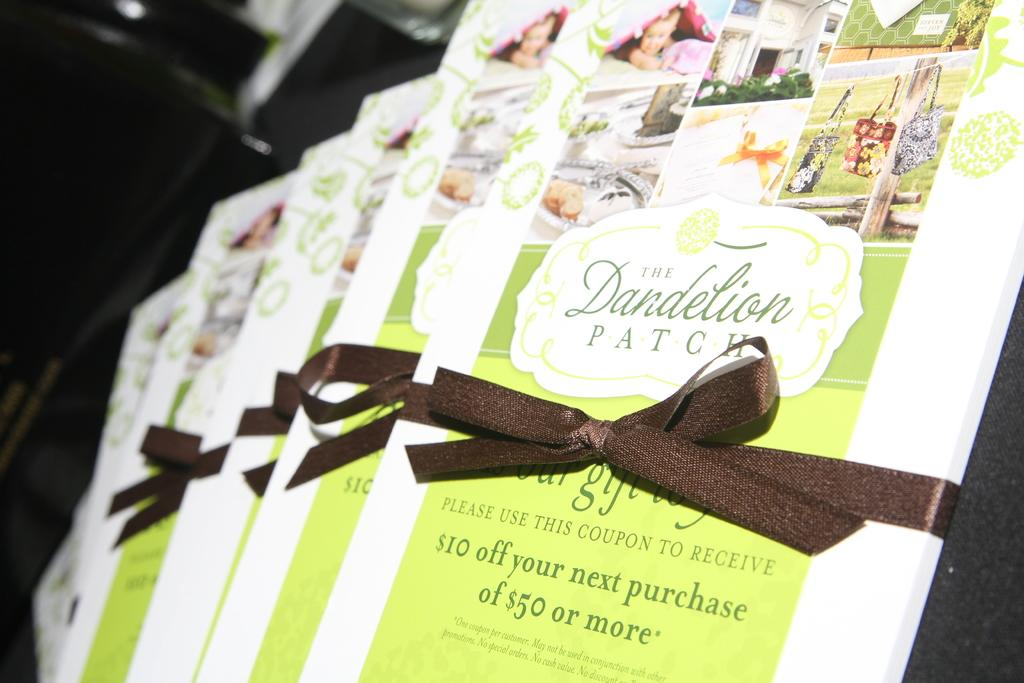What is the main subject of the image? The main subject of the image is a set of coupons. How are the coupons arranged in the image? The coupons are kept in an order. What type of grape is being used to hold the coupons together in the image? There is no grape present in the image; the coupons are not held together by any fruit. 